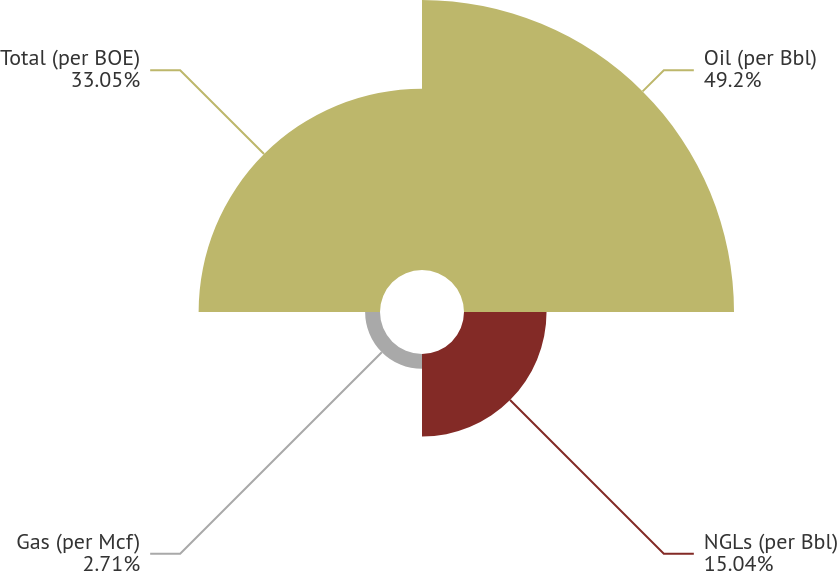Convert chart to OTSL. <chart><loc_0><loc_0><loc_500><loc_500><pie_chart><fcel>Oil (per Bbl)<fcel>NGLs (per Bbl)<fcel>Gas (per Mcf)<fcel>Total (per BOE)<nl><fcel>49.2%<fcel>15.04%<fcel>2.71%<fcel>33.05%<nl></chart> 